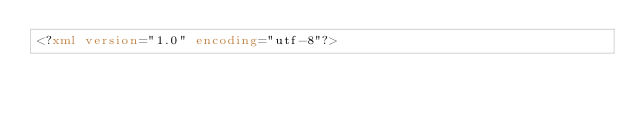<code> <loc_0><loc_0><loc_500><loc_500><_XML_><?xml version="1.0" encoding="utf-8"?></code> 